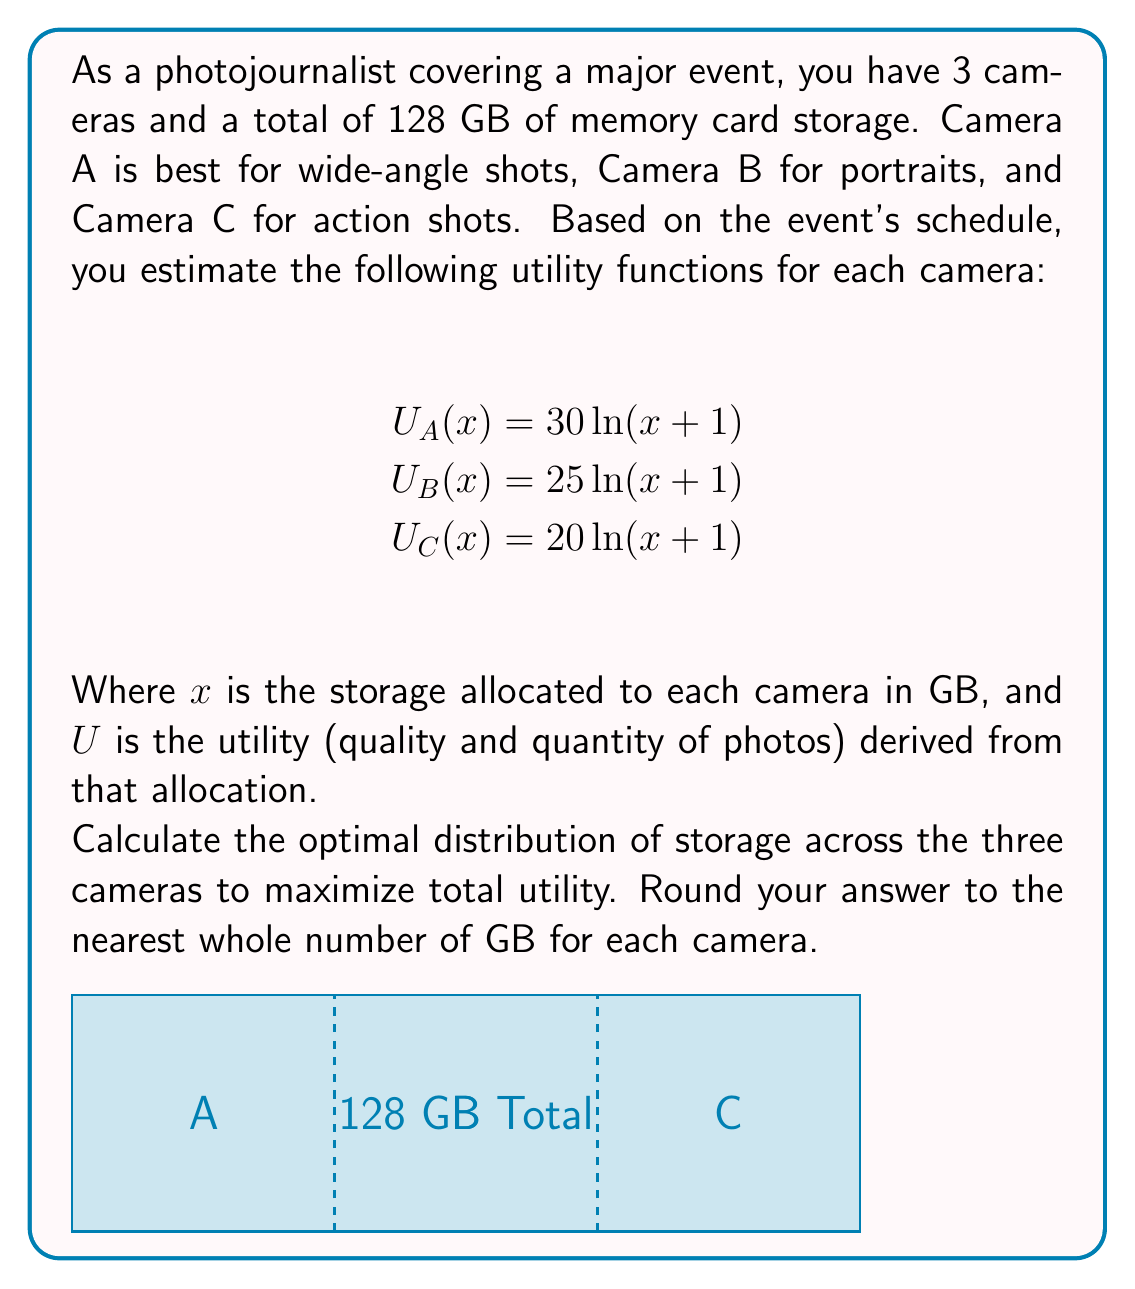Help me with this question. To solve this problem, we'll use the method of Lagrange multipliers:

1) Let $x$, $y$, and $z$ be the storage allocated to cameras A, B, and C respectively.

2) Our objective function is the total utility:
   $$U(x,y,z) = 30\ln(x+1) + 25\ln(y+1) + 20\ln(z+1)$$

3) The constraint is:
   $$x + y + z = 128$$

4) Form the Lagrangian:
   $$L(x,y,z,\lambda) = 30\ln(x+1) + 25\ln(y+1) + 20\ln(z+1) - \lambda(x+y+z-128)$$

5) Take partial derivatives and set them to zero:
   $$\frac{\partial L}{\partial x} = \frac{30}{x+1} - \lambda = 0$$
   $$\frac{\partial L}{\partial y} = \frac{25}{y+1} - \lambda = 0$$
   $$\frac{\partial L}{\partial z} = \frac{20}{z+1} - \lambda = 0$$
   $$\frac{\partial L}{\partial \lambda} = x + y + z - 128 = 0$$

6) From these equations, we can derive:
   $$x+1 = \frac{30}{\lambda}, y+1 = \frac{25}{\lambda}, z+1 = \frac{20}{\lambda}$$

7) Substituting into the constraint equation:
   $$(\frac{30}{\lambda} - 1) + (\frac{25}{\lambda} - 1) + (\frac{20}{\lambda} - 1) = 128$$
   $$\frac{75}{\lambda} - 3 = 128$$
   $$\frac{75}{\lambda} = 131$$
   $$\lambda = \frac{75}{131}$$

8) Now we can solve for x, y, and z:
   $$x = \frac{30}{\lambda} - 1 = \frac{30 \cdot 131}{75} - 1 \approx 51.4$$
   $$y = \frac{25}{\lambda} - 1 = \frac{25 \cdot 131}{75} - 1 \approx 42.5$$
   $$z = \frac{20}{\lambda} - 1 = \frac{20 \cdot 131}{75} - 1 \approx 33.1$$

9) Rounding to the nearest whole number:
   x ≈ 51 GB, y ≈ 43 GB, z ≈ 33 GB

This distribution ensures that the marginal utility per GB is equal across all cameras, maximizing total utility.
Answer: Camera A: 51 GB, Camera B: 43 GB, Camera C: 33 GB 